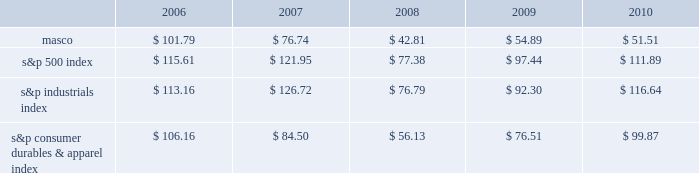Performance graph the table below compares the cumulative total shareholder return on our common stock with the cumulative total return of ( i ) the standard & poor 2019s 500 composite stock index ( 201cs&p 500 index 201d ) , ( ii ) the standard & poor 2019s industrials index ( 201cs&p industrials index 201d ) and ( iii ) the standard & poor 2019s consumer durables & apparel index ( 201cs&p consumer durables & apparel index 201d ) , from december 31 , 2005 through december 31 , 2010 , when the closing price of our common stock was $ 12.66 .
The graph assumes investments of $ 100 on december 31 , 2005 in our common stock and in each of the three indices and the reinvestment of dividends .
Performance graph 201020092008200720062005 s&p 500 index s&p industrials index s&p consumer durables & apparel index the table below sets forth the value , as of december 31 for each of the years indicated , of a $ 100 investment made on december 31 , 2005 in each of our common stock , the s&p 500 index , the s&p industrials index and the s&p consumer durables & apparel index and includes the reinvestment of dividends. .
In july 2007 , our board of directors authorized the purchase of up to 50 million shares of our common stock in open-market transactions or otherwise .
At december 31 , 2010 , we had remaining authorization to repurchase up to 27 million shares .
During 2010 , we repurchased and retired three million shares of our common stock , for cash aggregating $ 45 million to offset the dilutive impact of the 2010 grant of three million shares of long-term stock awards .
We did not purchase any shares during the three months ended december 31 , 2010. .
What was the percent of the increase in the s&p industrial index from 2006 to 2007? 
Rationale: the percent of the increase in the s&p industrial index performance was 11.9% from 2006 to 2007
Computations: ((126.72 - 113.16) / 113.16)
Answer: 0.11983. 